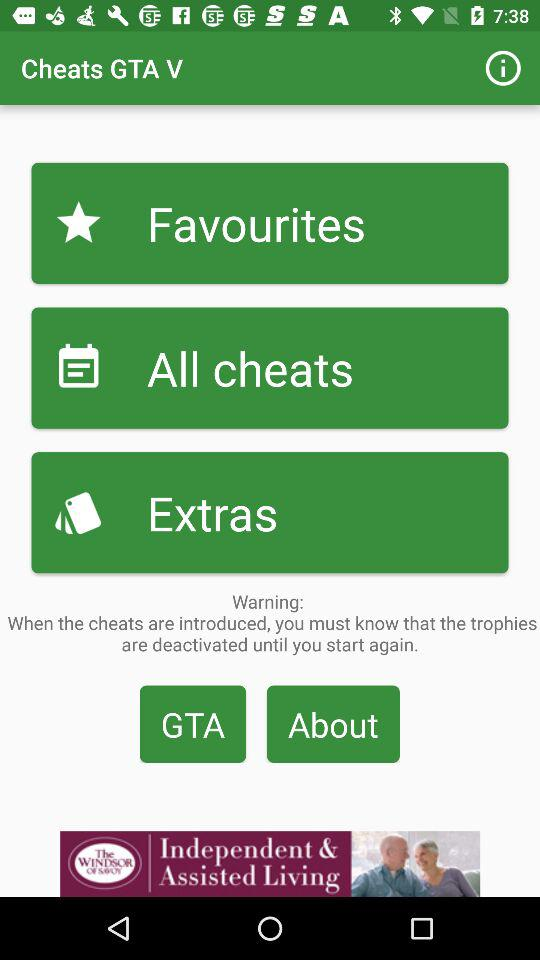What is the name of the application? The name of the application is "Cheats GTA V". 